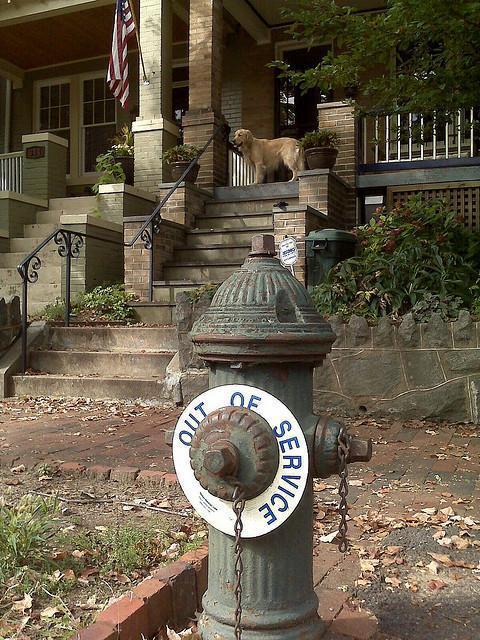How many people are wearing brown shirt?
Give a very brief answer. 0. 